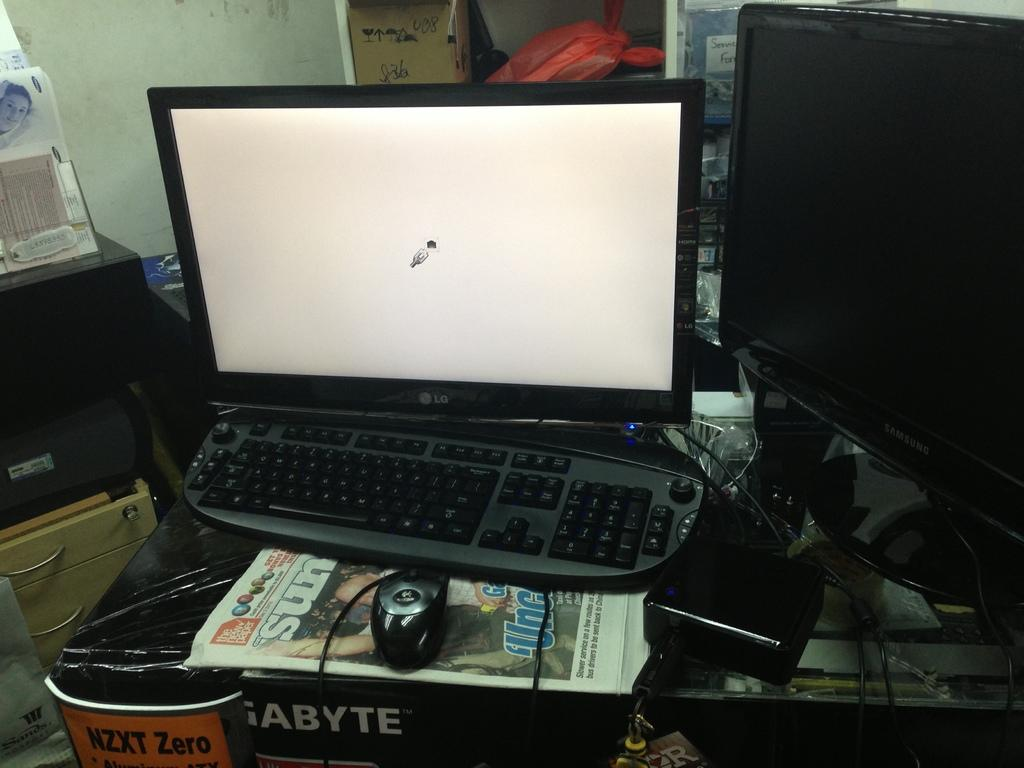<image>
Create a compact narrative representing the image presented. An LG laptop, a Samsung TV and a newspaper are among various items on this desk. 